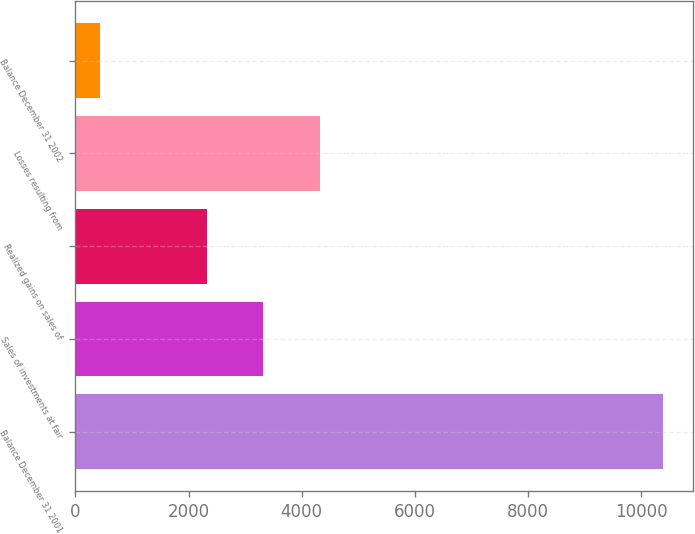<chart> <loc_0><loc_0><loc_500><loc_500><bar_chart><fcel>Balance December 31 2001<fcel>Sales of investments at fair<fcel>Realized gains on sales of<fcel>Losses resulting from<fcel>Balance December 31 2002<nl><fcel>10387<fcel>3321.1<fcel>2326<fcel>4316.2<fcel>436<nl></chart> 